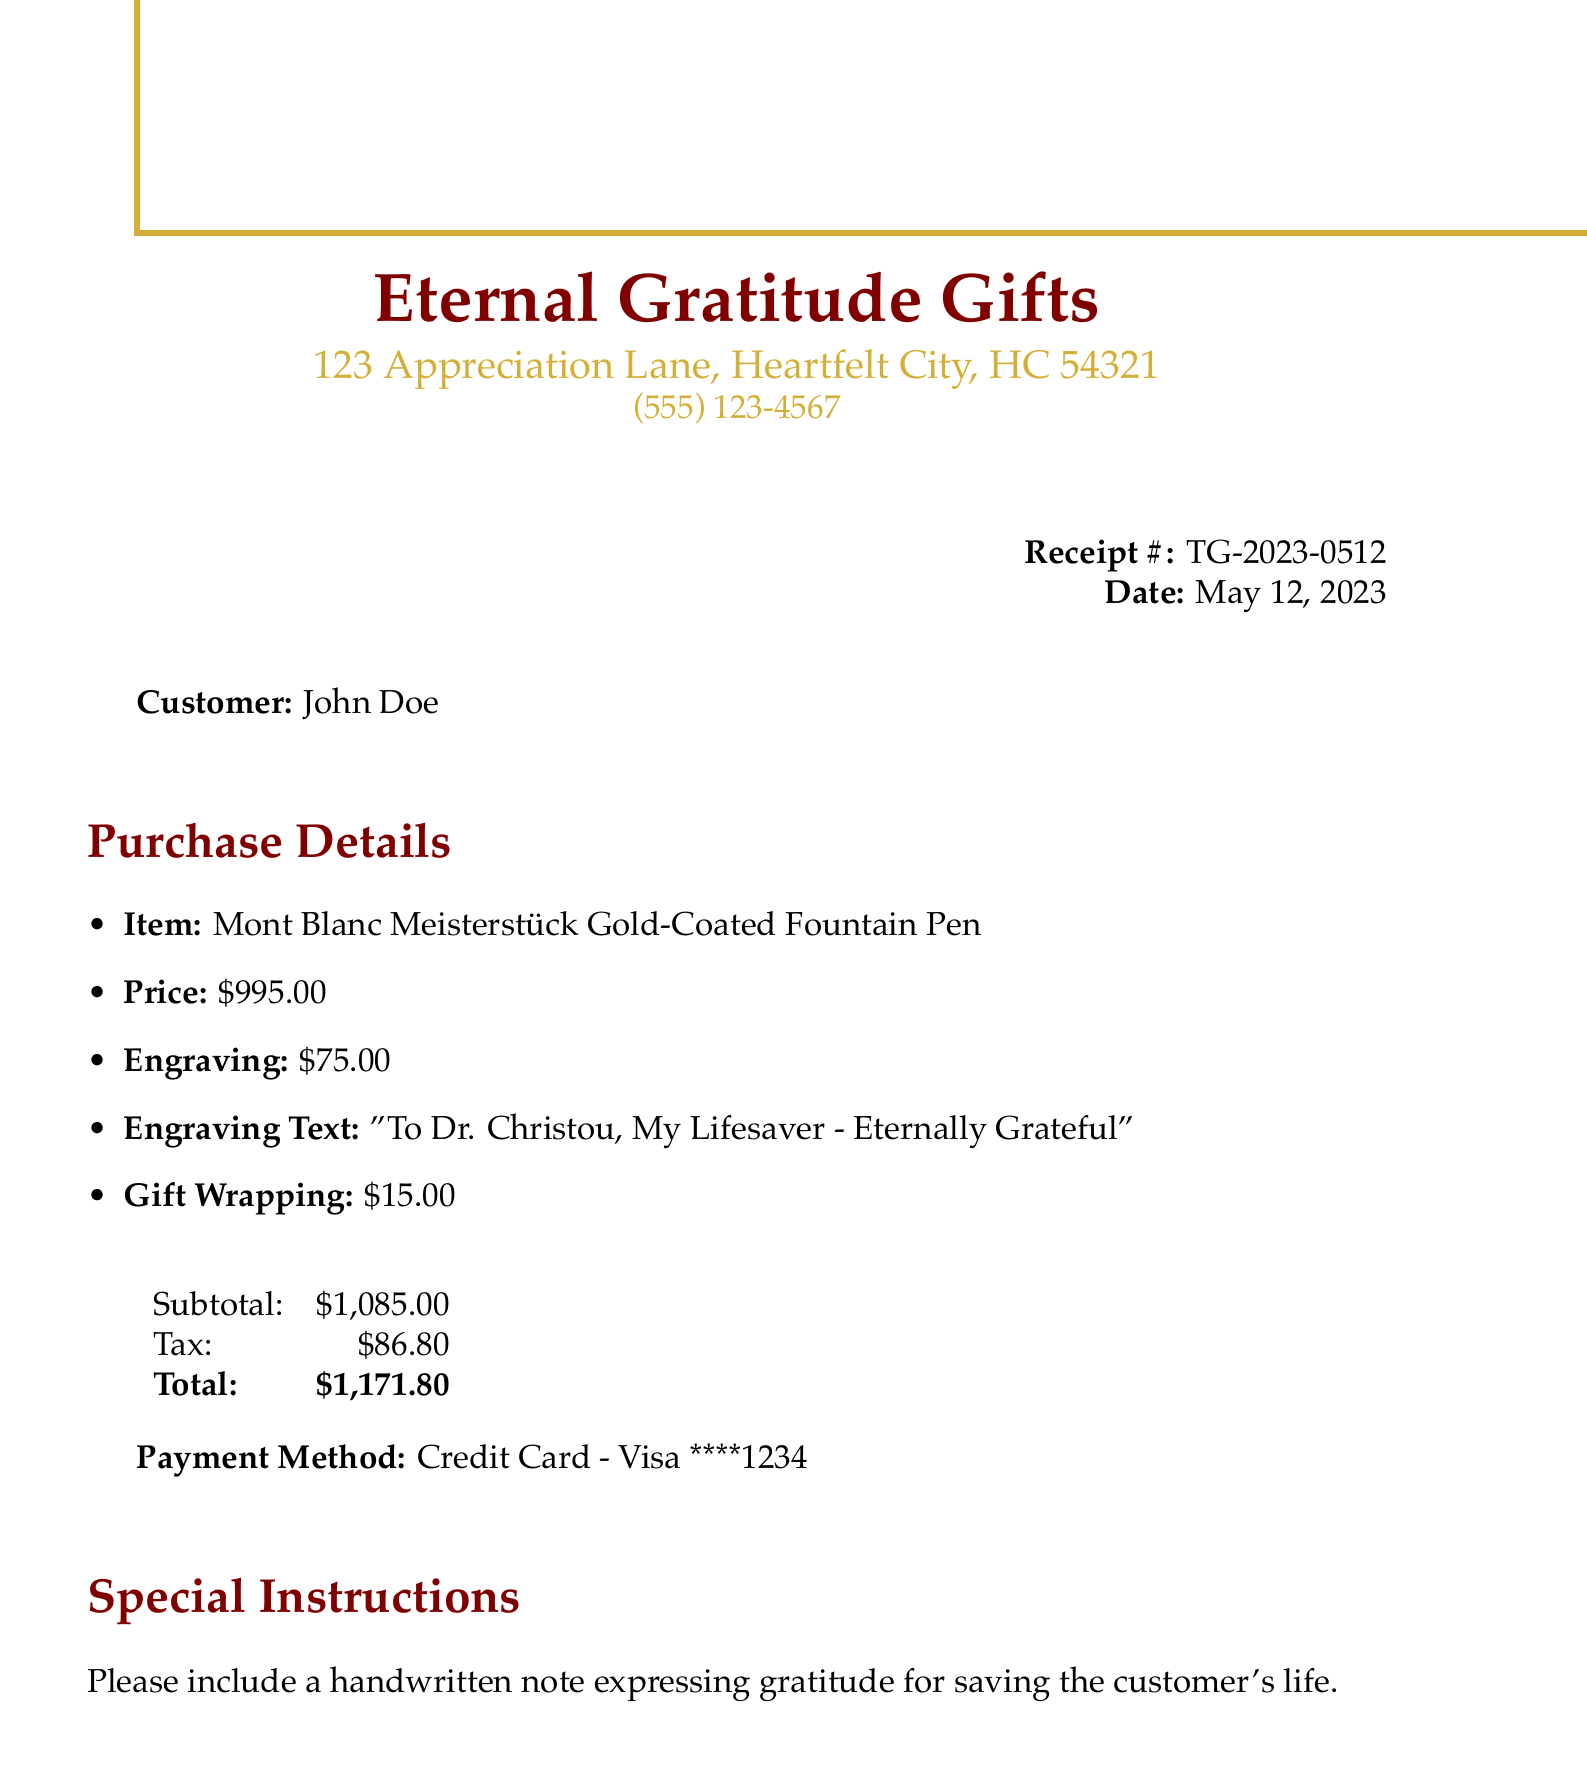What is the receipt number? The receipt number identifies this specific transaction, which is TG-2023-0512.
Answer: TG-2023-0512 Who is the customer? The customer name appears on the receipt and is John Doe.
Answer: John Doe What is the total amount spent? The total amount is the final sum on the receipt, which is $1,171.80.
Answer: $1,171.80 What item was purchased? The item purchased is listed prominently, which is a Mont Blanc Meisterstück Gold-Coated Fountain Pen.
Answer: Mont Blanc Meisterstück Gold-Coated Fountain Pen What was the engraving text? The engraving text is specified on the receipt, which reads, "To Dr. Christou, My Lifesaver - Eternally Grateful."
Answer: To Dr. Christou, My Lifesaver - Eternally Grateful What date was the purchase made? The date of the purchase is mentioned in the receipt as May 12, 2023.
Answer: May 12, 2023 How much was charged for the engraving service? The charge for the engraving service is clearly stated as $75.00.
Answer: $75.00 What special instructions were included with the purchase? The special instructions include a request for a handwritten note expressing gratitude.
Answer: Please include a handwritten note expressing gratitude for saving the customer's life What is the return policy for personalized items? The return policy states that personalized items are non-refundable, with specific conditions for store credit.
Answer: Personalized items are non-refundable. Store credit available within 30 days with receipt 